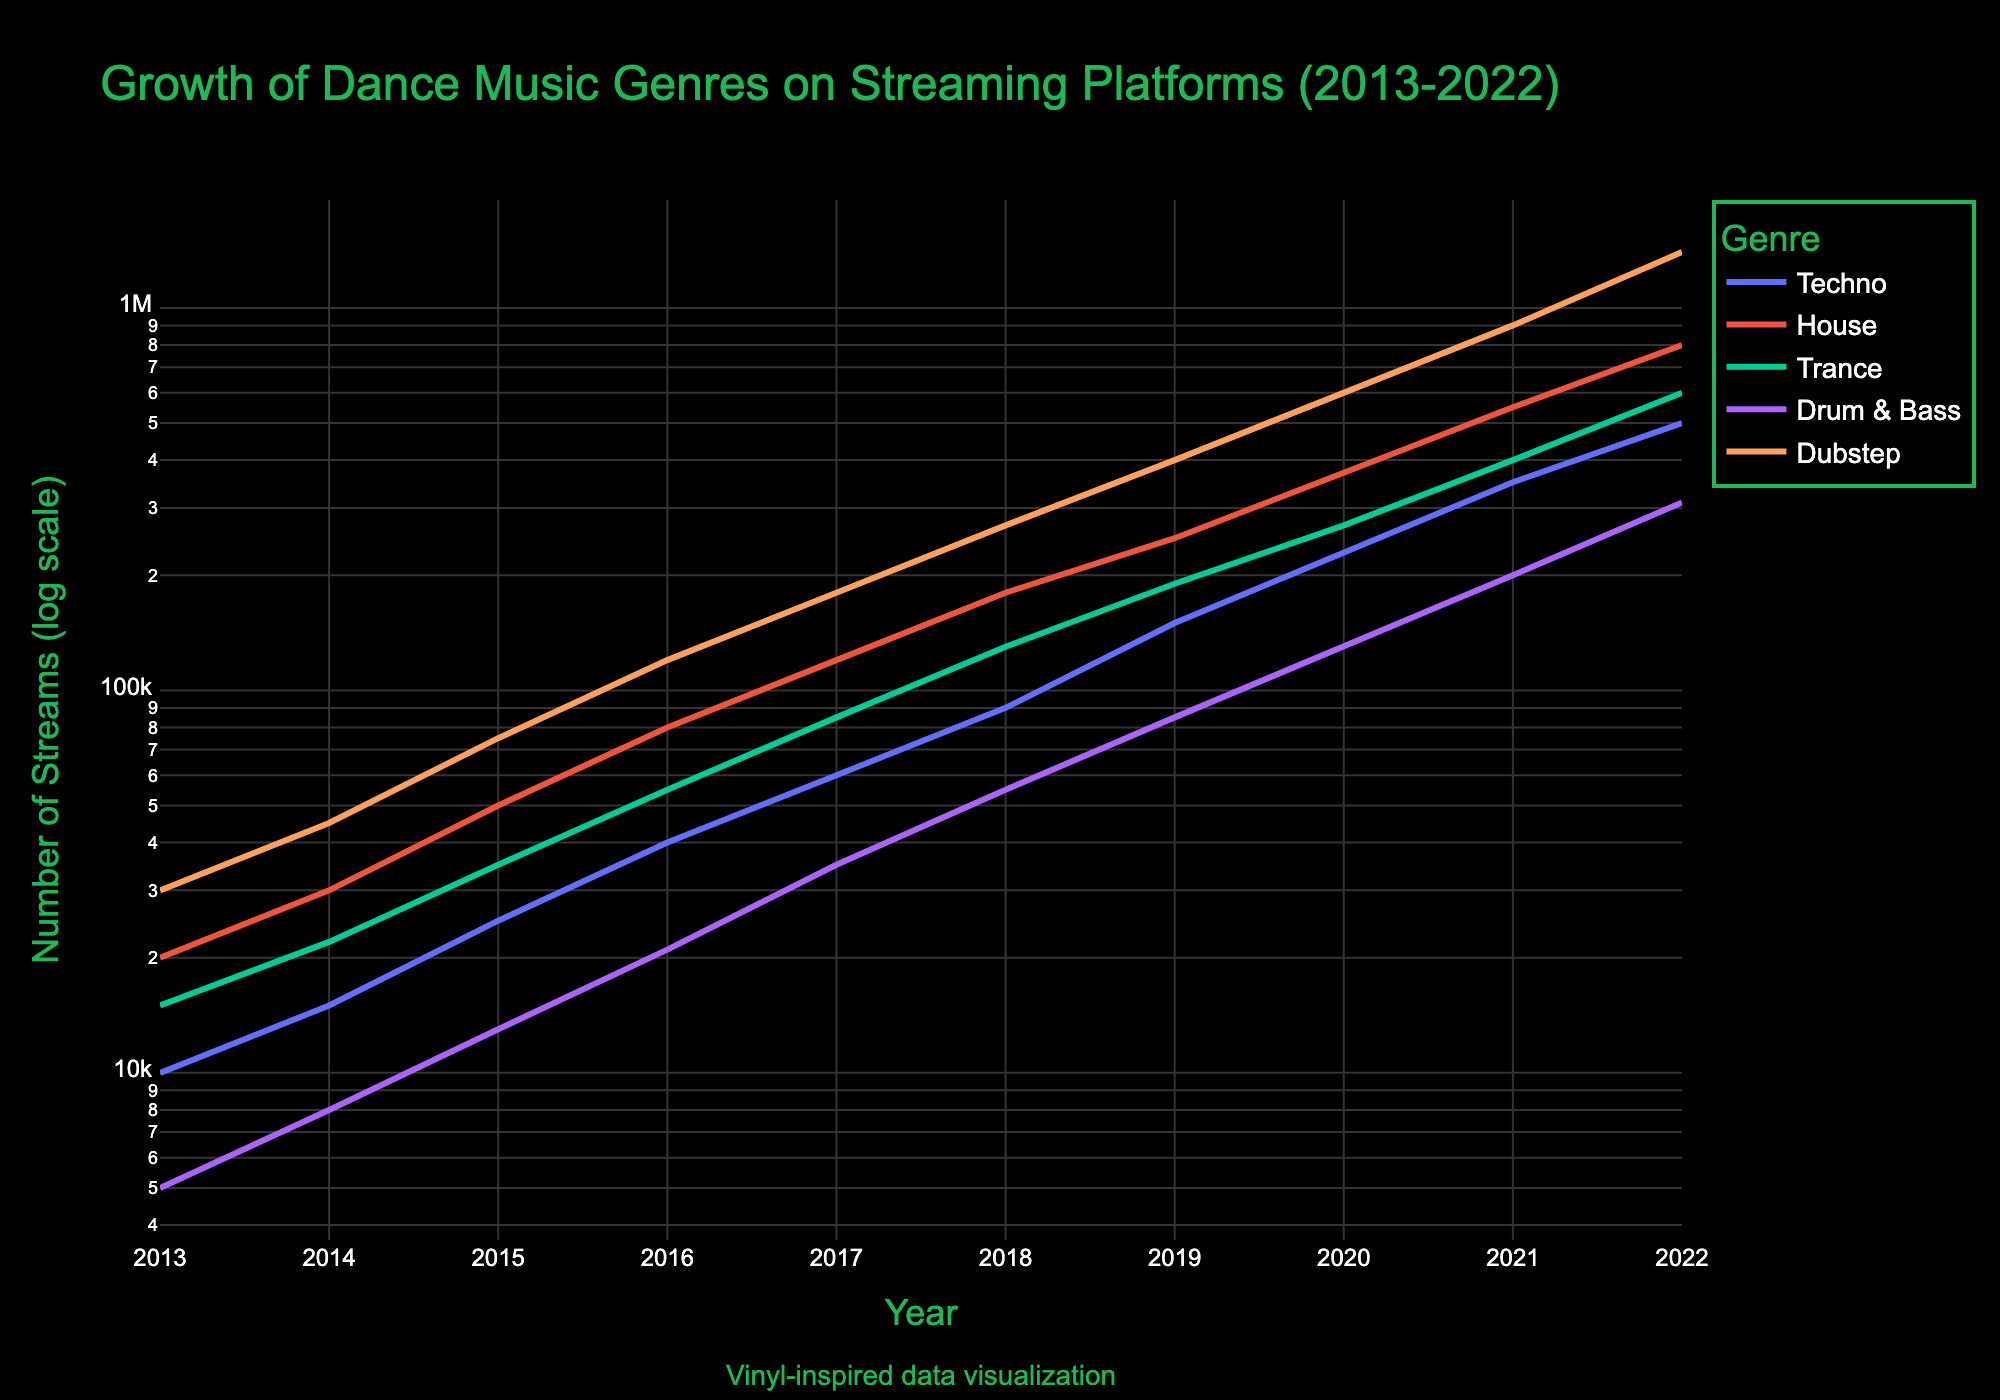How many genres are represented in the figure? The legend in the figure shows different colored lines representing each genre. There are distinct colors for Techno, House, Trance, Drum & Bass, and Dubstep.
Answer: 5 What is the y-axis scale used in the figure? The y-axis scale is in logarithmic form as indicated by "log scale" mentioned in the axis label. This scale is used to represent exponential growth effectively.
Answer: Log scale Which genre experienced the highest number of streams in 2022? By looking at the data points for 2022 along the y-axis (log scale), one can see that the data point for Dubstep is at the highest position compared to other genres.
Answer: Dubstep How did the growth rate of Drum & Bass compare to Techno from 2013 to 2022? The slope of the Drum & Bass line is steeper than the Techno line, especially noticeable after 2017, indicating that the growth rate of Drum & Bass is faster compared to Techno over the period.
Answer: Drum & Bass grew faster Calculate the average annual growth rate for Trance between 2013 and 2022. To calculate average annual growth rate: Identify the initial and final values: 15,000 in 2013 and 600,000 in 2022. Use the formula for average growth rate: (Final/Initial)^(1/Years) - 1. [(600,000/15,000)^(1/9) - 1] ≈ 0.50 or 50%.
Answer: 50% Which genre showed consistent exponential growth over the years? By examining the slopes of the lines over the log scale, genres with consistent upward slopes include Trance, as it shows a steady, exponential increase without any plateau periods.
Answer: Trance Compare the number of streams for House and Techno in 2019. Which one had more streams and by what factor? In 2019, House has 250,000 streams and Techno has 150,000 streams. To find the factor: 250,000 / 150,000 ≈ 1.67. So, House had 1.67 times more streams than Techno.
Answer: House by 1.67 times What were the total streams for Dubstep and Drum & Bass combined in 2020? For 2020, Dubstep had 600,000 streams and Drum & Bass had 130,000 streams. The total combined is 600,000 + 130,000 = 730,000.
Answer: 730,000 How does the visual representation of growth differ when using a log scale compared to a linear scale? In a log scale, exponential growth appears linear, making it easier to compare growth rates across genres. A linear scale would show an exaggerated curve for fast-growing genres, making detailed comparisons harder.
Answer: Exponential growth appears linear What does the annotation "Vinyl-inspired data visualization" refer to in the figure? The annotation suggests that the design and styling of the plot, including background color, font, and the vinyl icon, are influenced by the aesthetic of vinyl records, which aligns with the creator's inspiration and authenticity values.
Answer: It's about stylistic influence 